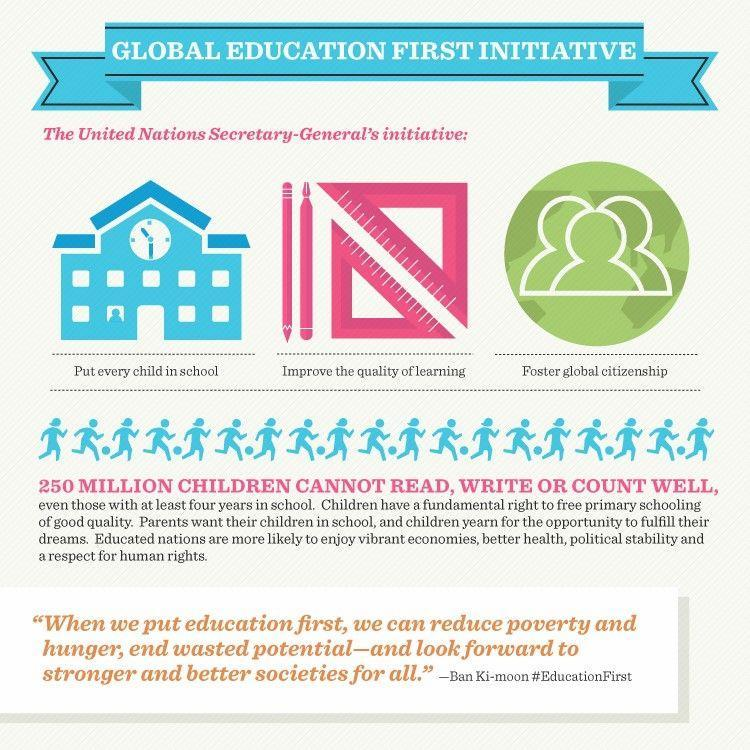what is the colour of the school building, red or blue
Answer the question with a short phrase. blue Who is the UN Secretary General Ban Ki-moon What are the initiatives of Ban ki-moon Put every child in school, Improve the quality of learning, Foster global citizenship what is the colour of the set-square, white or pink pink How many initiatives has Ban Ki-moon taken 3 